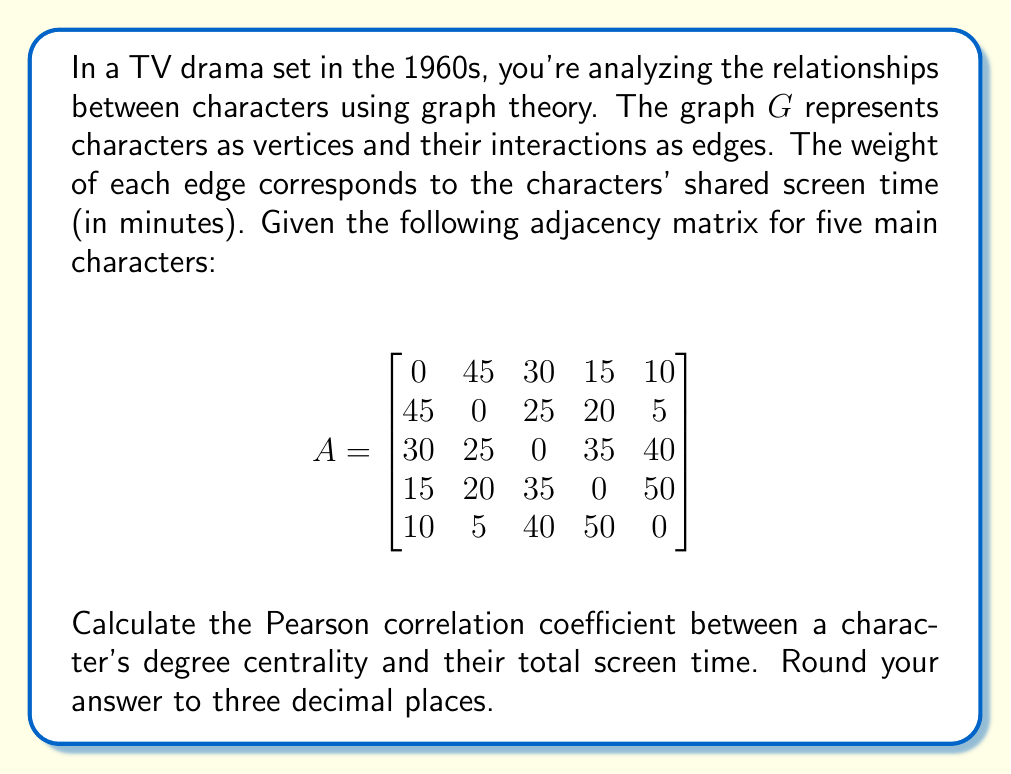Could you help me with this problem? To solve this problem, we'll follow these steps:

1. Calculate the degree centrality for each character.
2. Calculate the total screen time for each character.
3. Compute the Pearson correlation coefficient between degree centrality and total screen time.

Step 1: Degree Centrality
The degree centrality of a vertex is the sum of the weights of its incident edges, normalized by the maximum possible degree.

Maximum possible degree: $(n-1) \times \max(\text{edge weight}) = 4 \times 50 = 200$

For each character:
Character 1: $(45 + 30 + 15 + 10) / 200 = 0.5$
Character 2: $(45 + 25 + 20 + 5) / 200 = 0.475$
Character 3: $(30 + 25 + 35 + 40) / 200 = 0.65$
Character 4: $(15 + 20 + 35 + 50) / 200 = 0.6$
Character 5: $(10 + 5 + 40 + 50) / 200 = 0.525$

Step 2: Total Screen Time
Sum the rows (or columns) of the adjacency matrix:
Character 1: $45 + 30 + 15 + 10 = 100$
Character 2: $45 + 25 + 20 + 5 = 95$
Character 3: $30 + 25 + 35 + 40 = 130$
Character 4: $15 + 20 + 35 + 50 = 120$
Character 5: $10 + 5 + 40 + 50 = 105$

Step 3: Pearson Correlation Coefficient
Let $X$ be the degree centrality and $Y$ be the total screen time.

$r = \frac{\sum_{i=1}^{n} (x_i - \bar{x})(y_i - \bar{y})}{\sqrt{\sum_{i=1}^{n} (x_i - \bar{x})^2} \sqrt{\sum_{i=1}^{n} (y_i - \bar{y})^2}}$

Calculate means:
$\bar{x} = \frac{0.5 + 0.475 + 0.65 + 0.6 + 0.525}{5} = 0.55$
$\bar{y} = \frac{100 + 95 + 130 + 120 + 105}{5} = 110$

Calculate numerator and denominator:
$\sum (x_i - \bar{x})(y_i - \bar{y}) = 62.5$
$\sum (x_i - \bar{x})^2 = 0.02625$
$\sum (y_i - \bar{y})^2 = 875$

Pearson correlation coefficient:
$r = \frac{62.5}{\sqrt{0.02625} \sqrt{875}} \approx 0.987$
Answer: 0.987 